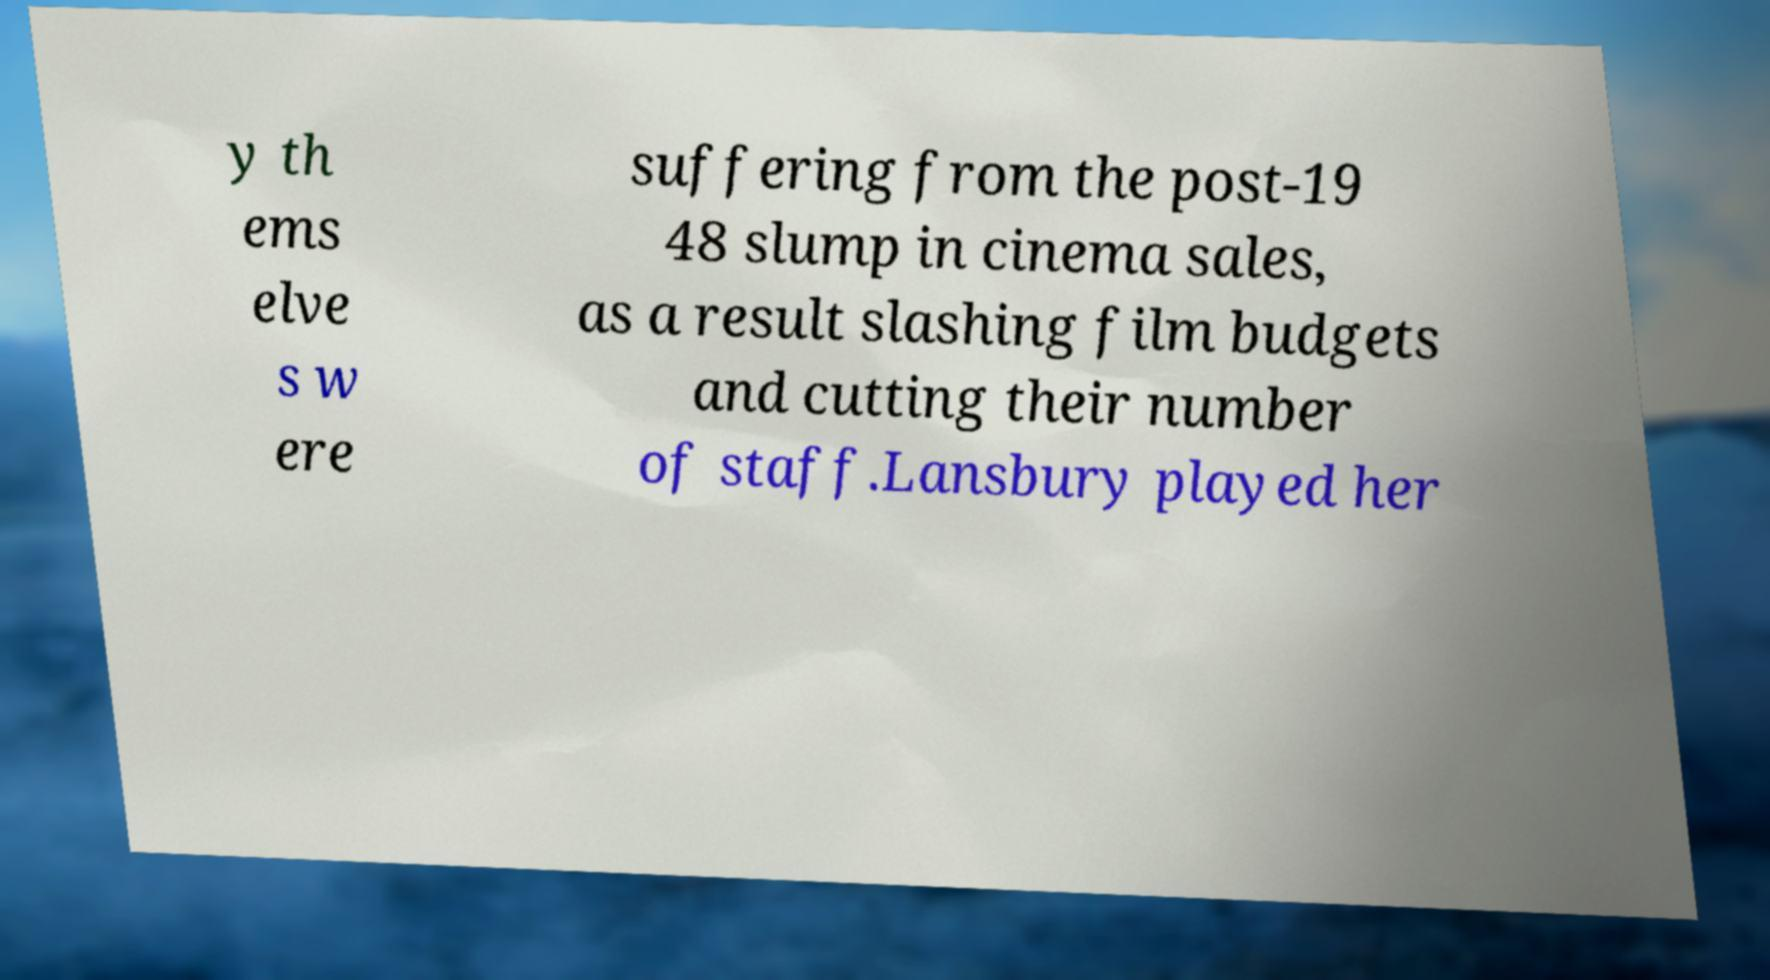What messages or text are displayed in this image? I need them in a readable, typed format. y th ems elve s w ere suffering from the post-19 48 slump in cinema sales, as a result slashing film budgets and cutting their number of staff.Lansbury played her 